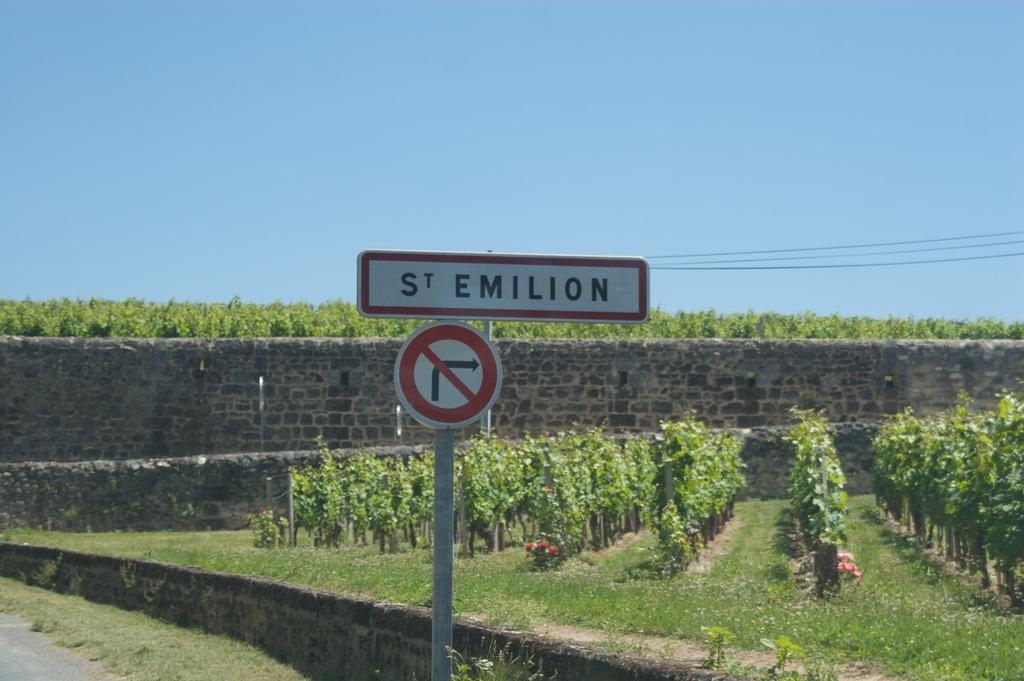In one or two sentences, can you explain what this image depicts? In this image we can see some plants, trees, grass, flowers, there is a sign board, a board with some text on it, also we can see the wall, and the sky. 